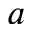Convert formula to latex. <formula><loc_0><loc_0><loc_500><loc_500>a</formula> 